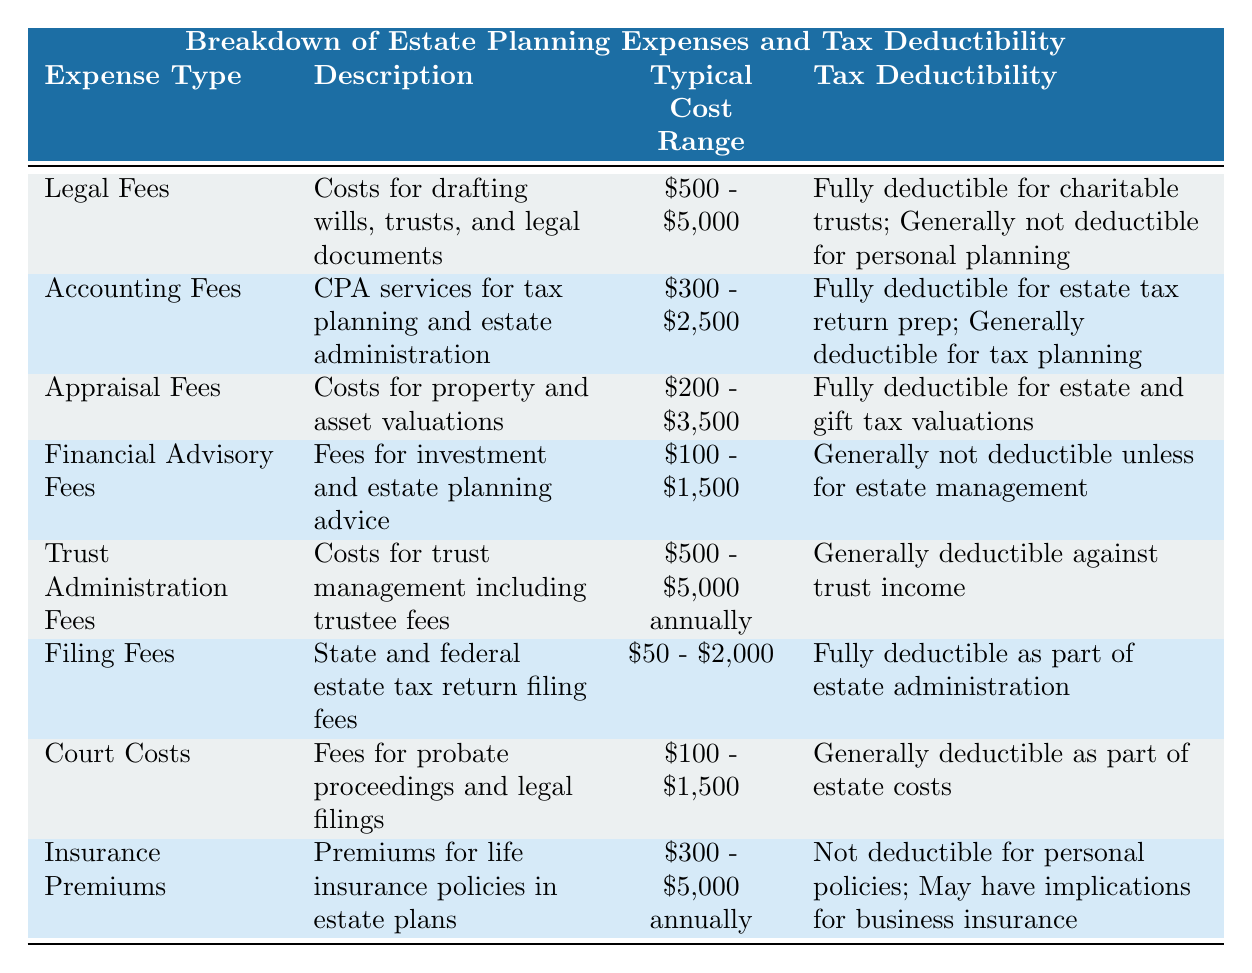What is the typical cost range for legal fees in estate planning? The table specifies that the typical cost range for legal fees is between $500 and $5,000.
Answer: $500 - $5,000 Can appraisal fees for estate valuations be deducted from taxes? According to the table, appraisal fees for estate valuations are fully deductible as part of the estate tax calculation.
Answer: Yes Are financial advisory fees generally deductible? The table indicates that financial advisory fees are generally not deductible unless they are for estate management purposes.
Answer: No What is the difference in typical cost ranges between accounting fees and court costs? The typical cost range for accounting fees is $300 - $2,500, while court costs range from $100 - $1,500. To find the difference in the maximum values, subtract $1,500 from $2,500 which equals $1,000.
Answer: $1,000 How many expense types in the table are fully deductible? The expense types that are fully deductible include legal fees (for charitable trusts), accounting fees (for estate tax return preparation), appraisal fees (for estate and gift tax valuations), and filing fees. There are four such expense types in total.
Answer: 4 Which expense has the lowest typical cost range? Comparing the typical cost ranges in the table, filing fees have the lowest range at $50 to $2,000.
Answer: Filing Fees Is it true that insurance premiums for personal policies are deductible? The table states that insurance premiums for personal life insurance policies are not deductible. Therefore, the statement is false.
Answer: No What is the total number of deductions that can be made related to estate and gift tax valuations? The deductions related to estate and gift tax valuations can be made under appraisal fees and are stated as fully deductible for both. That amounts to two deductions.
Answer: 2 Calculating the sum of the maximum values of the typical cost ranges for accounting and filing fees, what is that total? The maximum value for accounting fees is $2,500 and for filing fees, it is $2,000. Adding these gives $2,500 + $2,000 = $4,500.
Answer: $4,500 How many types of expenses are generally not deductible? The table lists insurance premiums and financial advisory fees as generally not deductible, leading to a total of two expense types.
Answer: 2 